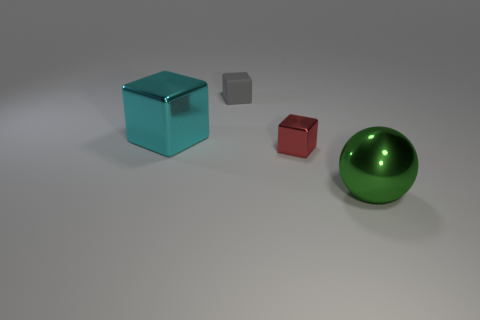There is a large metallic object behind the big thing on the right side of the cyan metallic thing; how many small red things are on the left side of it?
Offer a terse response. 0. Is the shape of the big cyan object the same as the object that is to the right of the small red block?
Ensure brevity in your answer.  No. Are there more big blocks than large yellow cylinders?
Provide a succinct answer. Yes. There is a large object that is on the right side of the big cyan metallic block; is its shape the same as the small gray matte object?
Your answer should be compact. No. Is the number of red shiny things on the right side of the gray object greater than the number of gray balls?
Ensure brevity in your answer.  Yes. There is a big metallic ball that is in front of the small block that is in front of the big cyan metal object; what color is it?
Your answer should be compact. Green. What number of large things are there?
Ensure brevity in your answer.  2. What number of large metal objects are left of the tiny gray rubber object and on the right side of the red metallic cube?
Your answer should be very brief. 0. Is there any other thing that is the same shape as the green metallic thing?
Offer a terse response. No. What is the shape of the big object that is to the left of the green sphere?
Make the answer very short. Cube. 